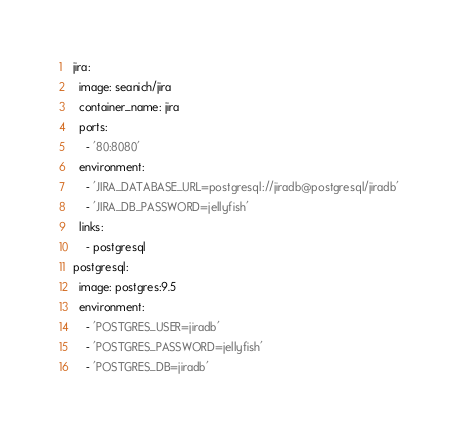Convert code to text. <code><loc_0><loc_0><loc_500><loc_500><_YAML_>jira:
  image: seanich/jira
  container_name: jira
  ports:
    - '80:8080'
  environment:
    - 'JIRA_DATABASE_URL=postgresql://jiradb@postgresql/jiradb'
    - 'JIRA_DB_PASSWORD=jellyfish'
  links:
    - postgresql
postgresql:
  image: postgres:9.5
  environment:
    - 'POSTGRES_USER=jiradb'
    - 'POSTGRES_PASSWORD=jellyfish'
    - 'POSTGRES_DB=jiradb'
</code> 